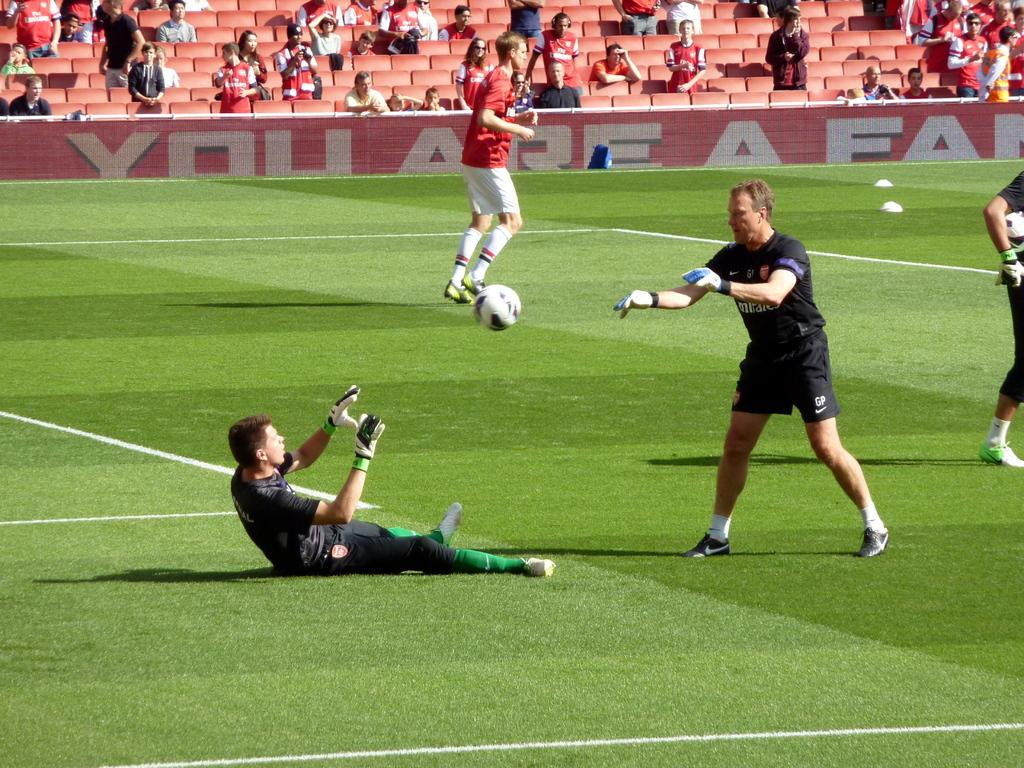<image>
Offer a succinct explanation of the picture presented. a football game with the words Your are a .. on the advertising hoard. 